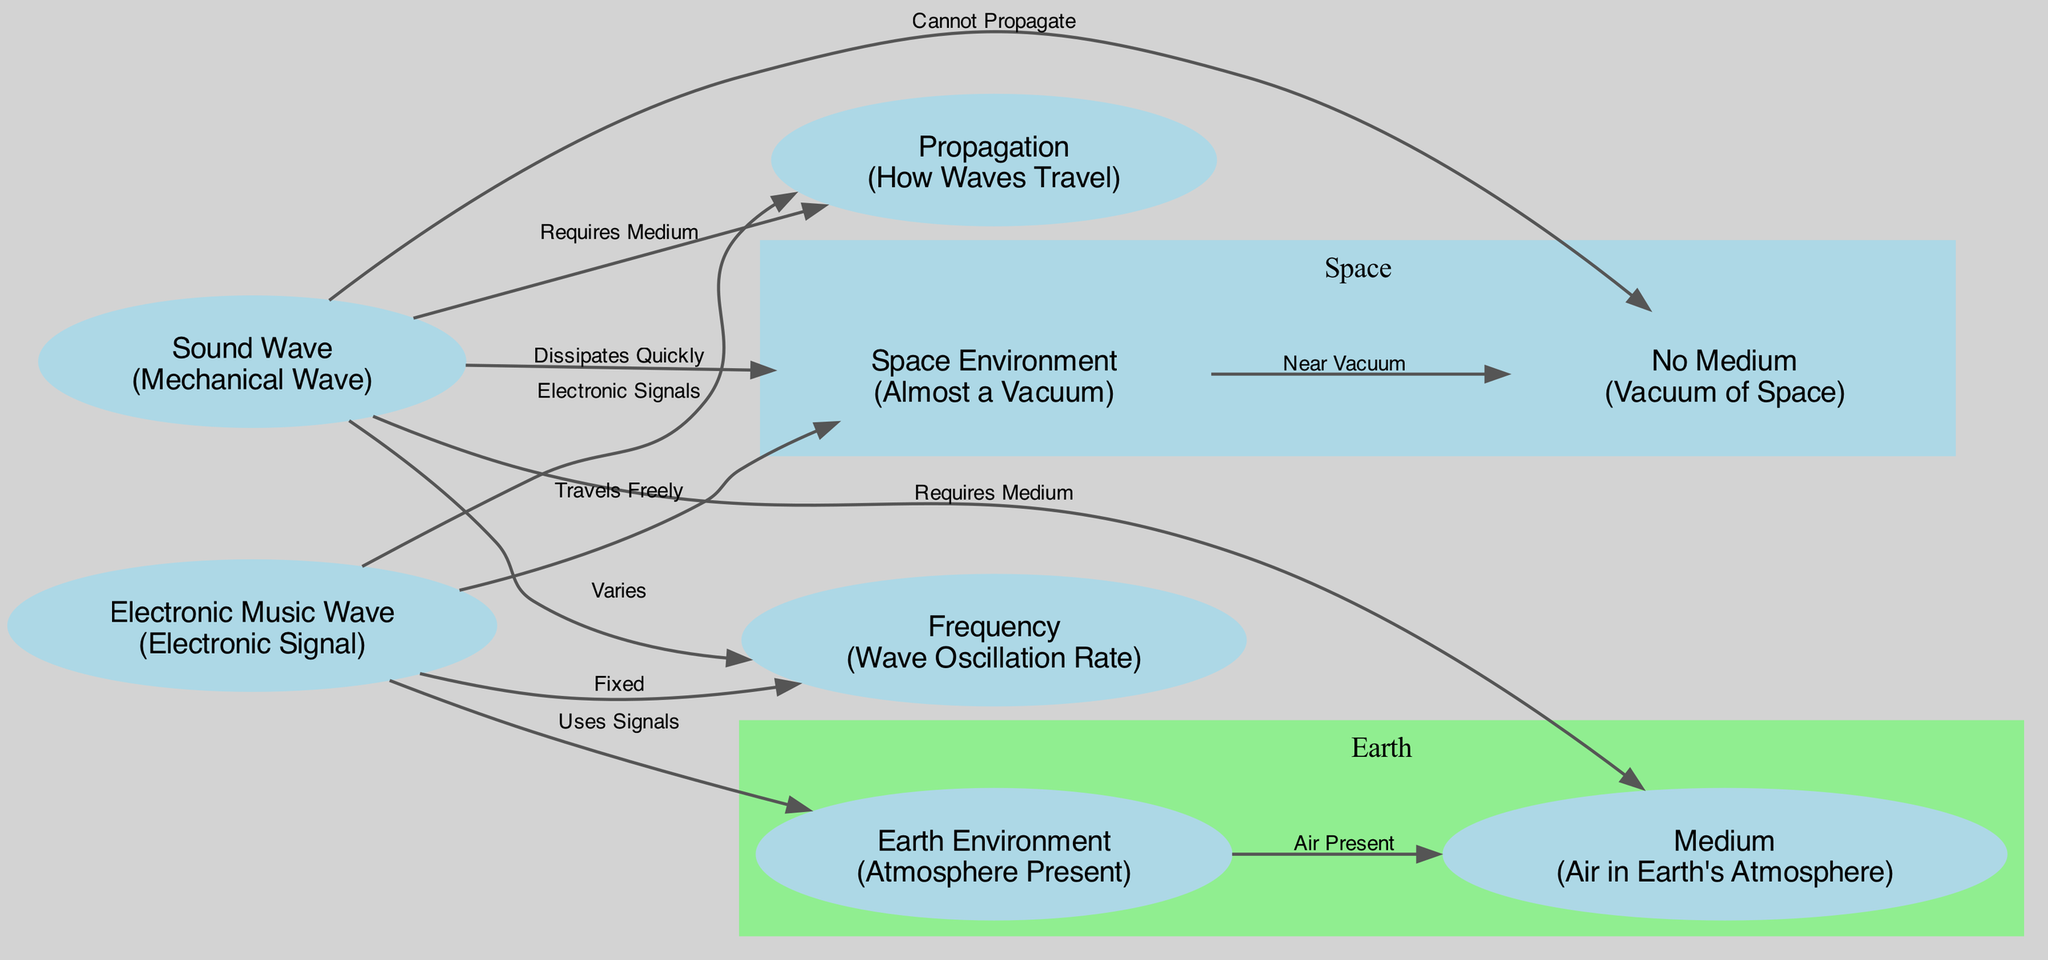What type of wave is a sound wave? The node labeled "Sound Wave" describes it as a "Mechanical Wave," which indicates its nature as a wave requiring a medium for propagation.
Answer: Mechanical Wave How does a sound wave behave in space? The diagram indicates that a sound wave "Dissipates Quickly" in space, highlighting its inability to travel effectively in a nearly vacuum environment.
Answer: Dissipates Quickly What is required for sound wave propagation? The diagram states that sound waves "Require Medium," which refers to the necessity of air or another medium for transmission.
Answer: Medium What type of medium do electronic music waves require? The edge from "Electronic Music Wave" to "Earth" shows that electronic music waves "Use Signals," implying they do not require a physical medium like air but can travel through signals in various environments.
Answer: Signals Which wave varies in frequency? The diagram specifies that the sound wave "Varies" in frequency, suggesting its oscillations can change, whereas electronic music waves have a "Fixed" frequency.
Answer: Sound Wave What does the space environment represent in terms of medium? The node labeled "Space Environment" describes it as "Almost a Vacuum," emphasizing the lack of a traditional medium necessary for sound propagation.
Answer: Almost a Vacuum How does an electronic music wave behave in space? The diagram states that an electronic music wave "Travels Freely" in space, indicating that it is not impeded by the absence of a medium.
Answer: Travels Freely How many nodes are in the diagram? By counting all distinct nodes presented for the space and earth environments, the total number of nodes in the diagram is eight.
Answer: Eight What type of wave is used for electronic music? The node labeled "Electronic Music Wave" describes it as an "Electronic Signal," showing its digital nature compared to sound waves.
Answer: Electronic Signal What is meant by the term 'frequency' in the context of the waves? The term 'Frequency' in the diagram refers to the "Wave Oscillation Rate," indicating how quickly the wave oscillates per unit of time, affecting the sound and music perceived.
Answer: Wave Oscillation Rate 